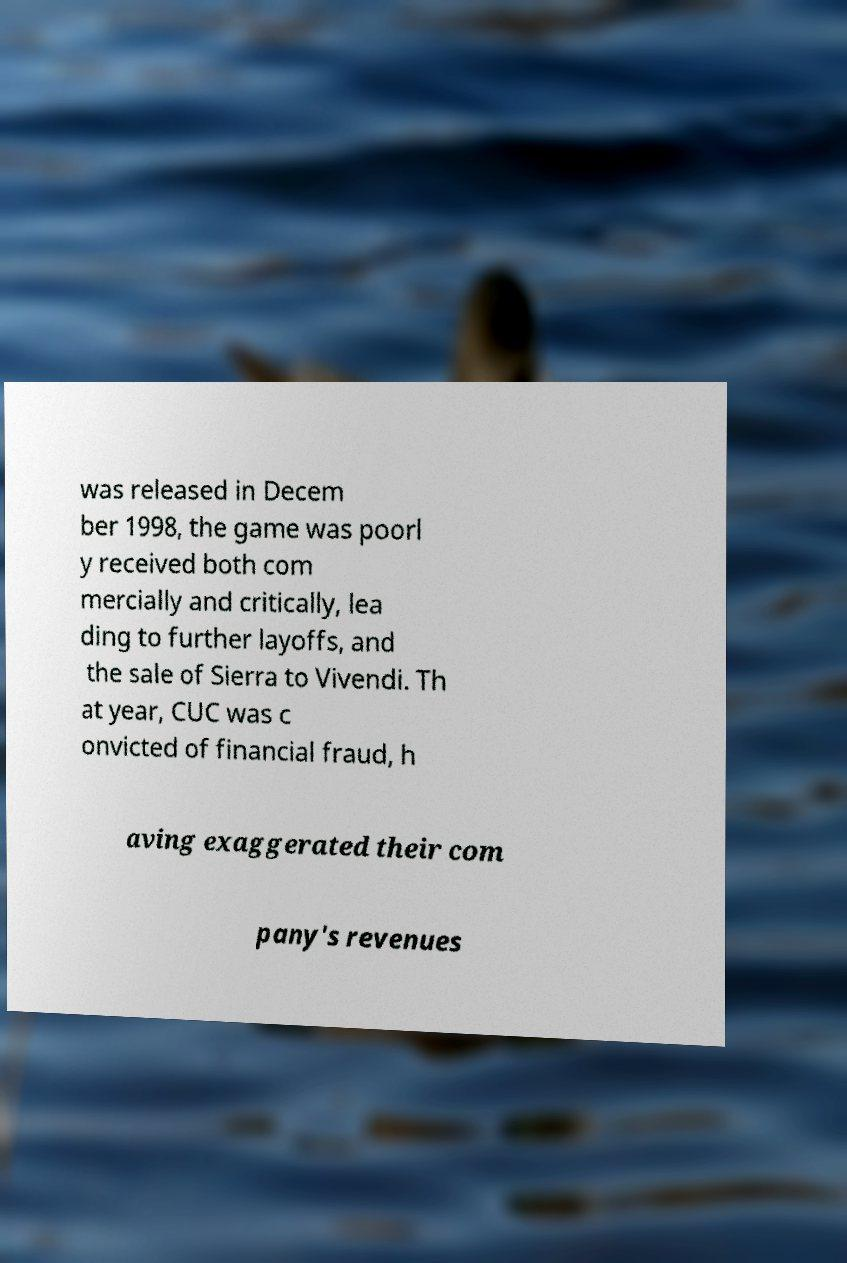Please read and relay the text visible in this image. What does it say? was released in Decem ber 1998, the game was poorl y received both com mercially and critically, lea ding to further layoffs, and the sale of Sierra to Vivendi. Th at year, CUC was c onvicted of financial fraud, h aving exaggerated their com pany's revenues 